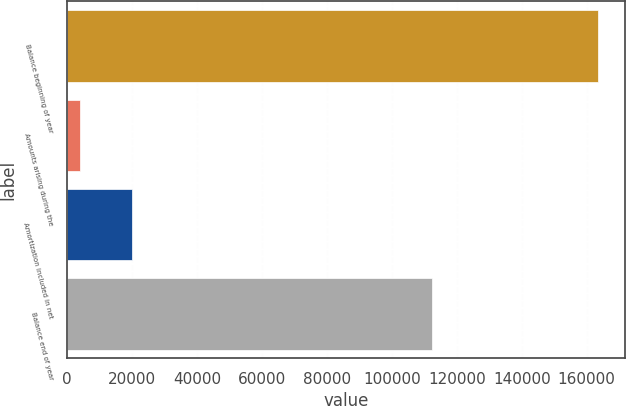Convert chart to OTSL. <chart><loc_0><loc_0><loc_500><loc_500><bar_chart><fcel>Balance beginning of year<fcel>Amounts arising during the<fcel>Amortization included in net<fcel>Balance end of year<nl><fcel>163575<fcel>4001<fcel>19958.4<fcel>112468<nl></chart> 